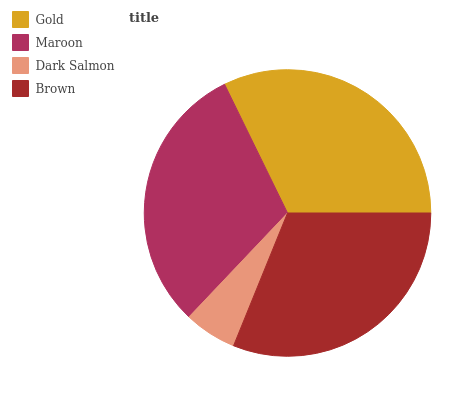Is Dark Salmon the minimum?
Answer yes or no. Yes. Is Gold the maximum?
Answer yes or no. Yes. Is Maroon the minimum?
Answer yes or no. No. Is Maroon the maximum?
Answer yes or no. No. Is Gold greater than Maroon?
Answer yes or no. Yes. Is Maroon less than Gold?
Answer yes or no. Yes. Is Maroon greater than Gold?
Answer yes or no. No. Is Gold less than Maroon?
Answer yes or no. No. Is Brown the high median?
Answer yes or no. Yes. Is Maroon the low median?
Answer yes or no. Yes. Is Dark Salmon the high median?
Answer yes or no. No. Is Brown the low median?
Answer yes or no. No. 